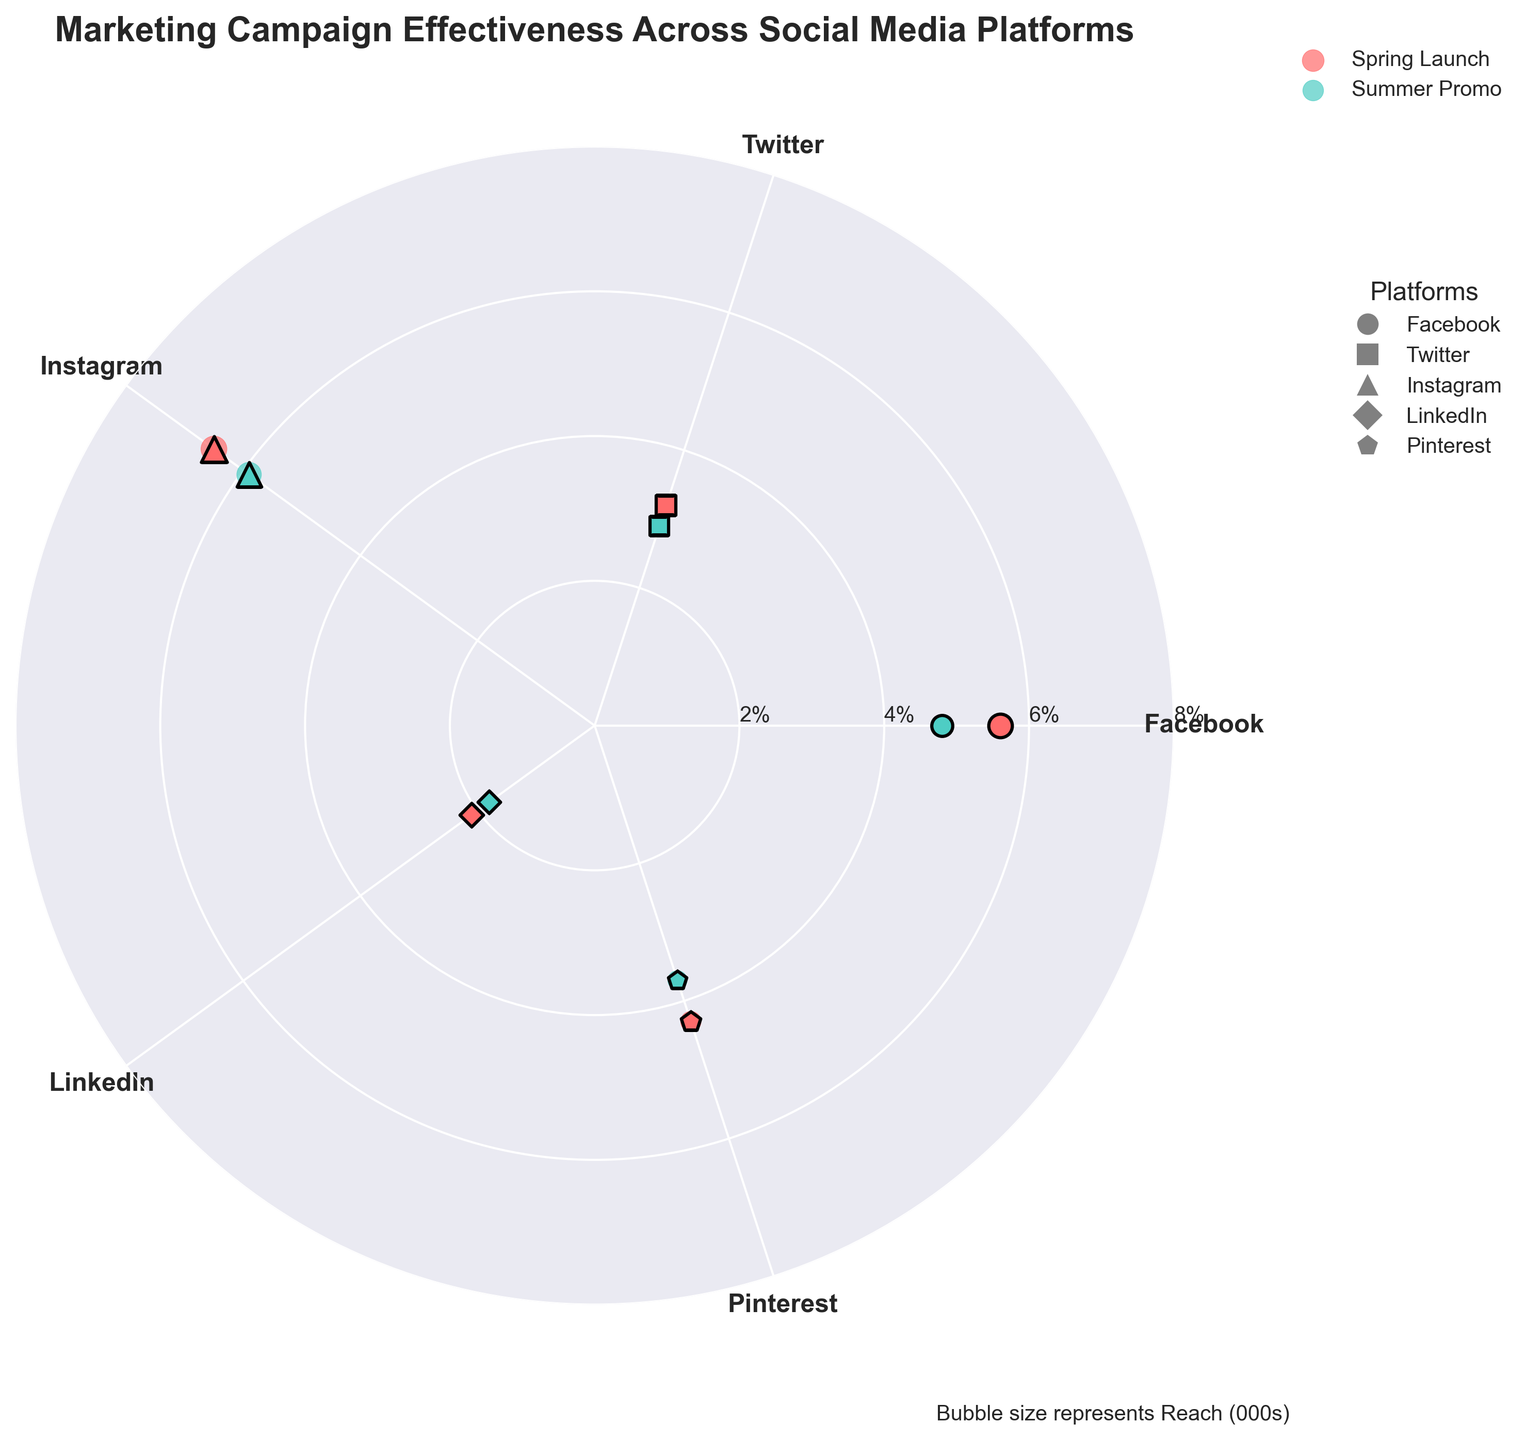Which platform has the highest engagement rate for the Spring Launch campaign? Check the engagement rates for the Spring Launch campaign across all platforms. The highest value is 6.5%.
Answer: Instagram What is the title of the plot? Look at the text at the top of the image.
Answer: Marketing Campaign Effectiveness Across Social Media Platforms Which campaign shows up with green bubbles? Identify the color coding for campaigns. Green bubbles correspond to the Summer Promo campaign.
Answer: Summer Promo How does Facebook's engagement rate for the Spring Launch compare to the Summer Promo? Look at the engagement rates for Facebook. Spring Launch is 5.6%, while Summer Promo is 4.8%.
Answer: Higher Which platform has the smallest reach during the Summer Promo campaign? Check the reach values for the Summer Promo campaign. The smallest value is 55.
Answer: LinkedIn What is the average engagement rate for Pinterest across both campaigns? Add the engagement rates for Pinterest's Spring Launch and Summer Promo, then divide by 2. (4.3% + 3.7%) / 2 = 4.0%
Answer: 4.0% Which platform has the lowest conversion rate for the Spring Launch campaign? Check the conversion rates for the Spring Launch campaign and find the lowest value. The lowest is 0.8%.
Answer: LinkedIn How many platforms are included in the chart? Count the number of unique platforms listed on the chart.
Answer: 5 Explain the meaning of the bubble size in this chart. Refer to the text explanation on the chart, which states the bubble size represents "Reach (000s)".
Answer: Reach Which platform-marker combination is unique to LinkedIn in the plot? Identify the specific marker used for LinkedIn, which is 'D'.
Answer: Diamond 